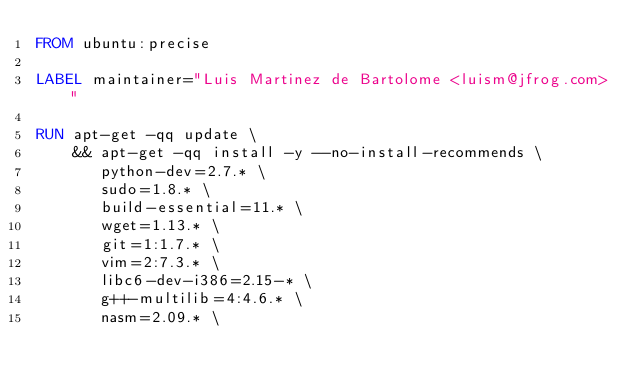<code> <loc_0><loc_0><loc_500><loc_500><_Dockerfile_>FROM ubuntu:precise

LABEL maintainer="Luis Martinez de Bartolome <luism@jfrog.com>"

RUN apt-get -qq update \
    && apt-get -qq install -y --no-install-recommends \
       python-dev=2.7.* \
       sudo=1.8.* \
       build-essential=11.* \
       wget=1.13.* \
       git=1:1.7.* \
       vim=2:7.3.* \
       libc6-dev-i386=2.15-* \
       g++-multilib=4:4.6.* \
       nasm=2.09.* \</code> 